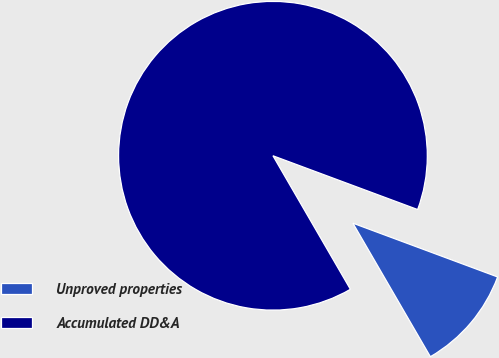<chart> <loc_0><loc_0><loc_500><loc_500><pie_chart><fcel>Unproved properties<fcel>Accumulated DD&A<nl><fcel>10.97%<fcel>89.03%<nl></chart> 